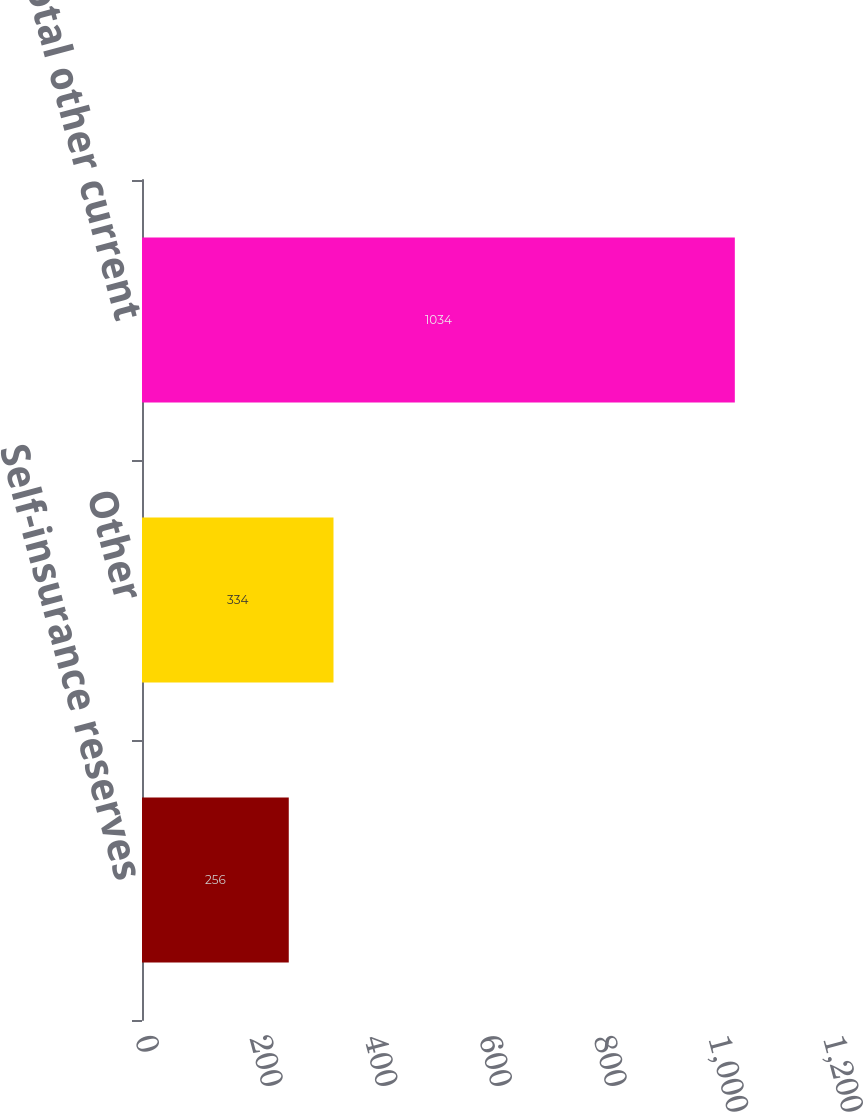Convert chart. <chart><loc_0><loc_0><loc_500><loc_500><bar_chart><fcel>Self-insurance reserves<fcel>Other<fcel>Total other current<nl><fcel>256<fcel>334<fcel>1034<nl></chart> 